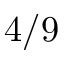<formula> <loc_0><loc_0><loc_500><loc_500>4 / 9</formula> 